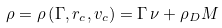Convert formula to latex. <formula><loc_0><loc_0><loc_500><loc_500>\rho = \rho \left ( \Gamma , r _ { c } , v _ { c } \right ) = \Gamma \, \nu + \rho _ { D } M</formula> 